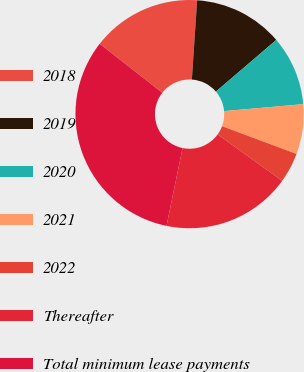<chart> <loc_0><loc_0><loc_500><loc_500><pie_chart><fcel>2018<fcel>2019<fcel>2020<fcel>2021<fcel>2022<fcel>Thereafter<fcel>Total minimum lease payments<nl><fcel>15.49%<fcel>12.68%<fcel>9.87%<fcel>7.07%<fcel>4.26%<fcel>18.3%<fcel>32.33%<nl></chart> 